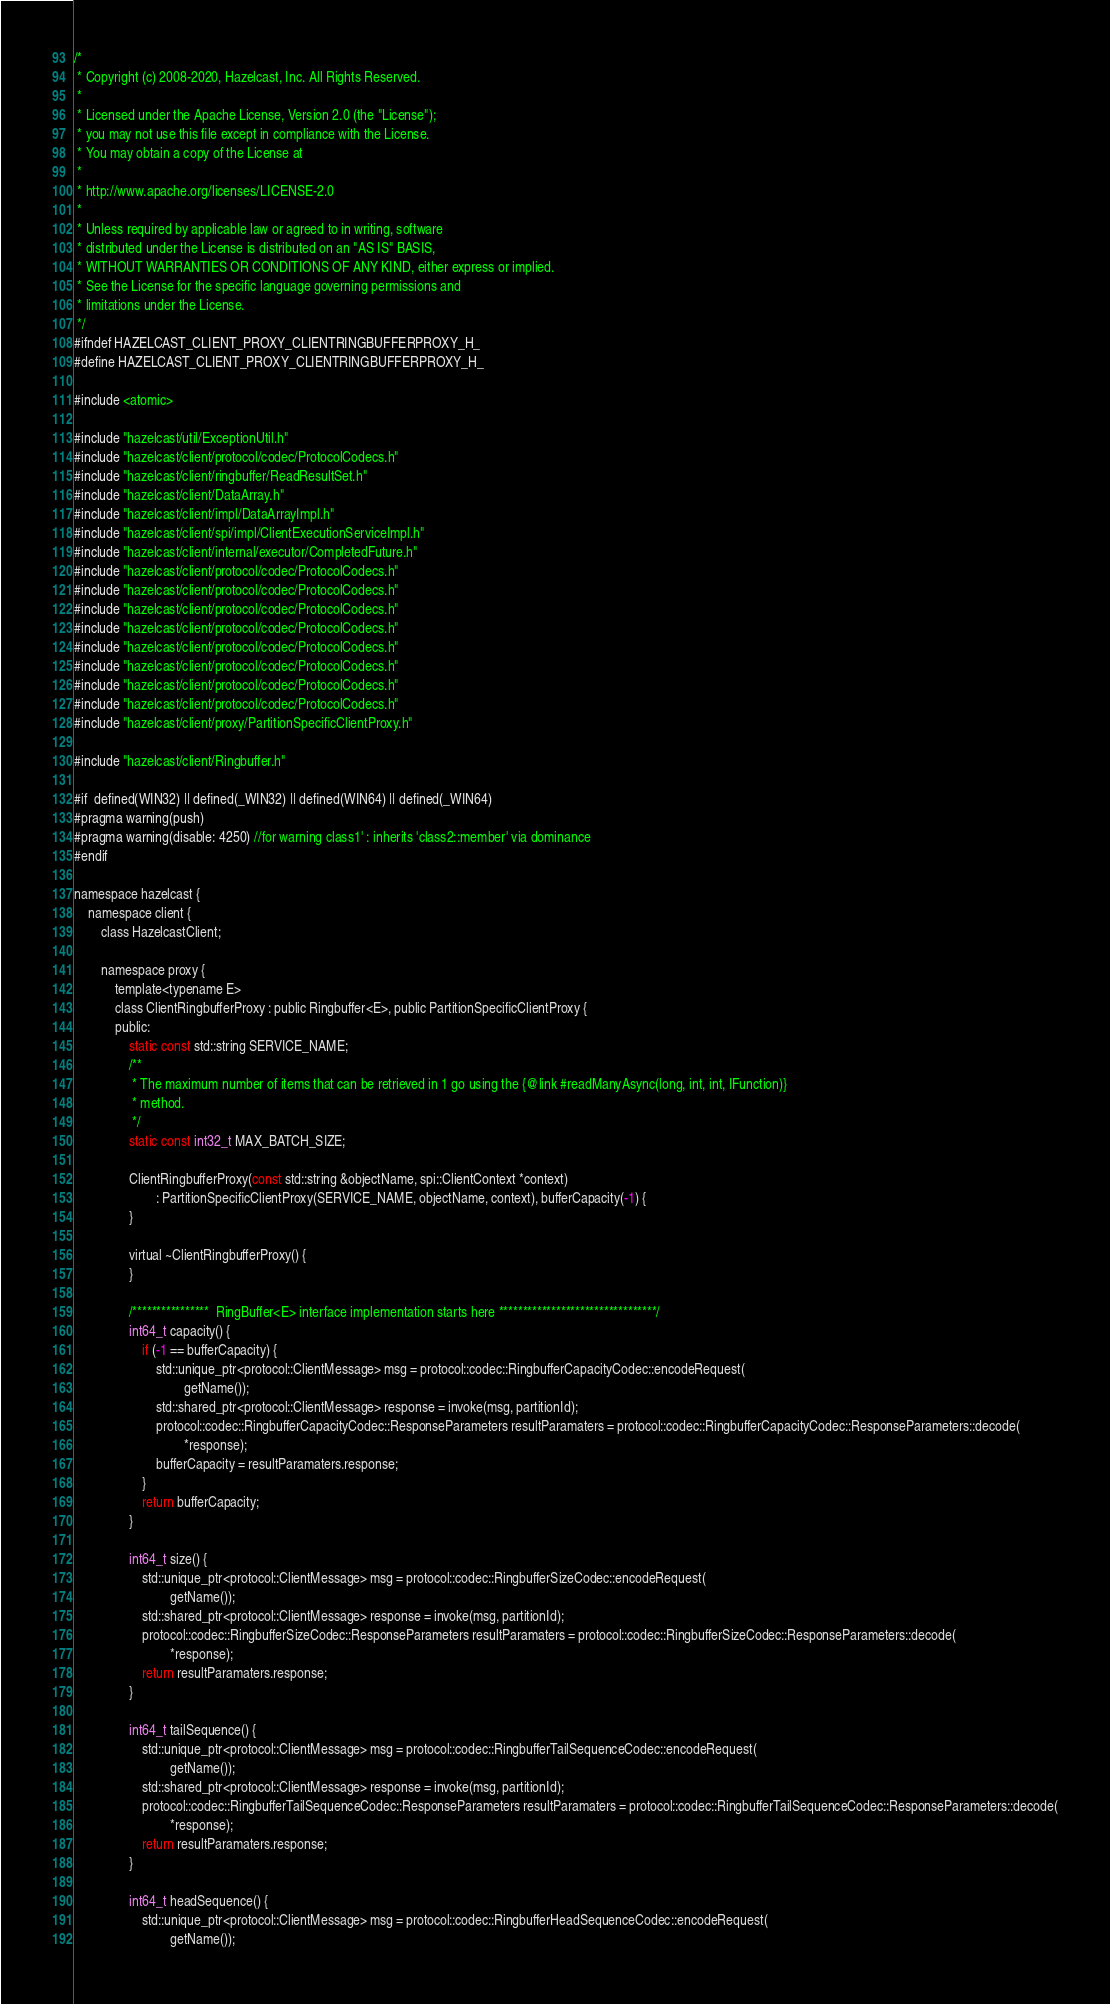<code> <loc_0><loc_0><loc_500><loc_500><_C_>/*
 * Copyright (c) 2008-2020, Hazelcast, Inc. All Rights Reserved.
 *
 * Licensed under the Apache License, Version 2.0 (the "License");
 * you may not use this file except in compliance with the License.
 * You may obtain a copy of the License at
 *
 * http://www.apache.org/licenses/LICENSE-2.0
 *
 * Unless required by applicable law or agreed to in writing, software
 * distributed under the License is distributed on an "AS IS" BASIS,
 * WITHOUT WARRANTIES OR CONDITIONS OF ANY KIND, either express or implied.
 * See the License for the specific language governing permissions and
 * limitations under the License.
 */
#ifndef HAZELCAST_CLIENT_PROXY_CLIENTRINGBUFFERPROXY_H_
#define HAZELCAST_CLIENT_PROXY_CLIENTRINGBUFFERPROXY_H_

#include <atomic>

#include "hazelcast/util/ExceptionUtil.h"
#include "hazelcast/client/protocol/codec/ProtocolCodecs.h"
#include "hazelcast/client/ringbuffer/ReadResultSet.h"
#include "hazelcast/client/DataArray.h"
#include "hazelcast/client/impl/DataArrayImpl.h"
#include "hazelcast/client/spi/impl/ClientExecutionServiceImpl.h"
#include "hazelcast/client/internal/executor/CompletedFuture.h"
#include "hazelcast/client/protocol/codec/ProtocolCodecs.h"
#include "hazelcast/client/protocol/codec/ProtocolCodecs.h"
#include "hazelcast/client/protocol/codec/ProtocolCodecs.h"
#include "hazelcast/client/protocol/codec/ProtocolCodecs.h"
#include "hazelcast/client/protocol/codec/ProtocolCodecs.h"
#include "hazelcast/client/protocol/codec/ProtocolCodecs.h"
#include "hazelcast/client/protocol/codec/ProtocolCodecs.h"
#include "hazelcast/client/protocol/codec/ProtocolCodecs.h"
#include "hazelcast/client/proxy/PartitionSpecificClientProxy.h"

#include "hazelcast/client/Ringbuffer.h"

#if  defined(WIN32) || defined(_WIN32) || defined(WIN64) || defined(_WIN64)
#pragma warning(push)
#pragma warning(disable: 4250) //for warning class1' : inherits 'class2::member' via dominance
#endif

namespace hazelcast {
    namespace client {
        class HazelcastClient;

        namespace proxy {
            template<typename E>
            class ClientRingbufferProxy : public Ringbuffer<E>, public PartitionSpecificClientProxy {
            public:
                static const std::string SERVICE_NAME;
                /**
                 * The maximum number of items that can be retrieved in 1 go using the {@link #readManyAsync(long, int, int, IFunction)}
                 * method.
                 */
                static const int32_t MAX_BATCH_SIZE;

                ClientRingbufferProxy(const std::string &objectName, spi::ClientContext *context)
                        : PartitionSpecificClientProxy(SERVICE_NAME, objectName, context), bufferCapacity(-1) {
                }

                virtual ~ClientRingbufferProxy() {
                }

                /****************  RingBuffer<E> interface implementation starts here *********************************/
                int64_t capacity() {
                    if (-1 == bufferCapacity) {
                        std::unique_ptr<protocol::ClientMessage> msg = protocol::codec::RingbufferCapacityCodec::encodeRequest(
                                getName());
                        std::shared_ptr<protocol::ClientMessage> response = invoke(msg, partitionId);
                        protocol::codec::RingbufferCapacityCodec::ResponseParameters resultParamaters = protocol::codec::RingbufferCapacityCodec::ResponseParameters::decode(
                                *response);
                        bufferCapacity = resultParamaters.response;
                    }
                    return bufferCapacity;
                }

                int64_t size() {
                    std::unique_ptr<protocol::ClientMessage> msg = protocol::codec::RingbufferSizeCodec::encodeRequest(
                            getName());
                    std::shared_ptr<protocol::ClientMessage> response = invoke(msg, partitionId);
                    protocol::codec::RingbufferSizeCodec::ResponseParameters resultParamaters = protocol::codec::RingbufferSizeCodec::ResponseParameters::decode(
                            *response);
                    return resultParamaters.response;
                }

                int64_t tailSequence() {
                    std::unique_ptr<protocol::ClientMessage> msg = protocol::codec::RingbufferTailSequenceCodec::encodeRequest(
                            getName());
                    std::shared_ptr<protocol::ClientMessage> response = invoke(msg, partitionId);
                    protocol::codec::RingbufferTailSequenceCodec::ResponseParameters resultParamaters = protocol::codec::RingbufferTailSequenceCodec::ResponseParameters::decode(
                            *response);
                    return resultParamaters.response;
                }

                int64_t headSequence() {
                    std::unique_ptr<protocol::ClientMessage> msg = protocol::codec::RingbufferHeadSequenceCodec::encodeRequest(
                            getName());</code> 